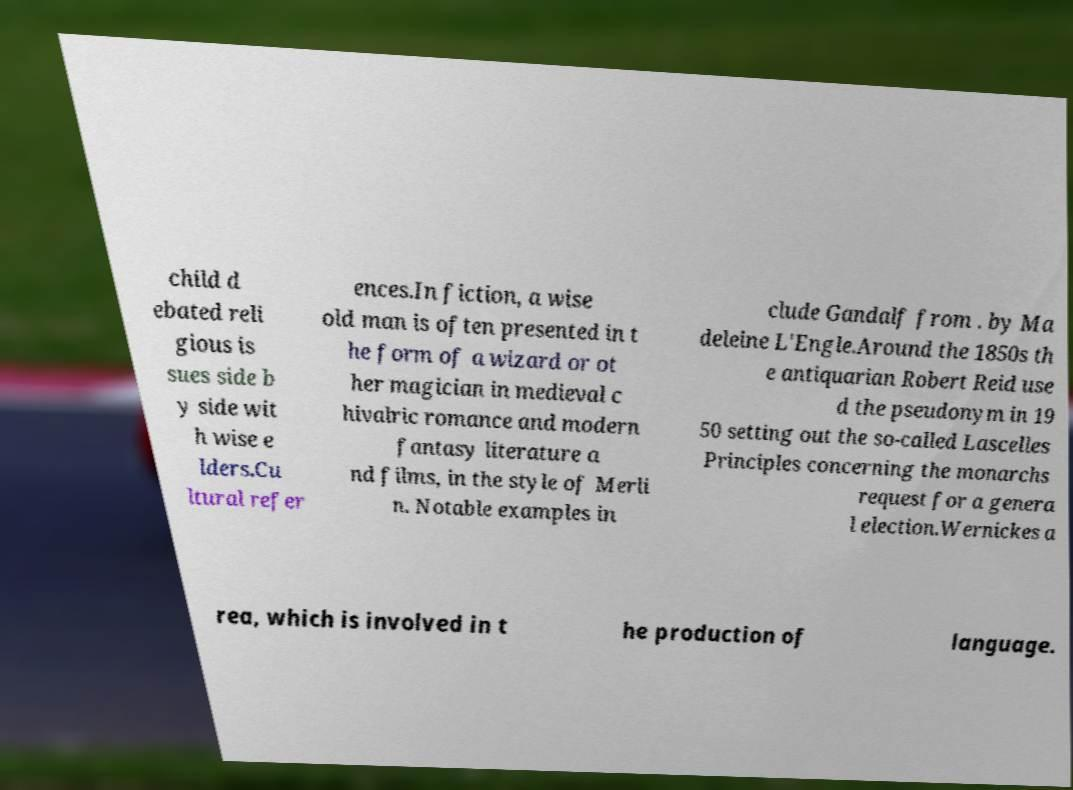Can you read and provide the text displayed in the image?This photo seems to have some interesting text. Can you extract and type it out for me? child d ebated reli gious is sues side b y side wit h wise e lders.Cu ltural refer ences.In fiction, a wise old man is often presented in t he form of a wizard or ot her magician in medieval c hivalric romance and modern fantasy literature a nd films, in the style of Merli n. Notable examples in clude Gandalf from . by Ma deleine L'Engle.Around the 1850s th e antiquarian Robert Reid use d the pseudonym in 19 50 setting out the so-called Lascelles Principles concerning the monarchs request for a genera l election.Wernickes a rea, which is involved in t he production of language. 